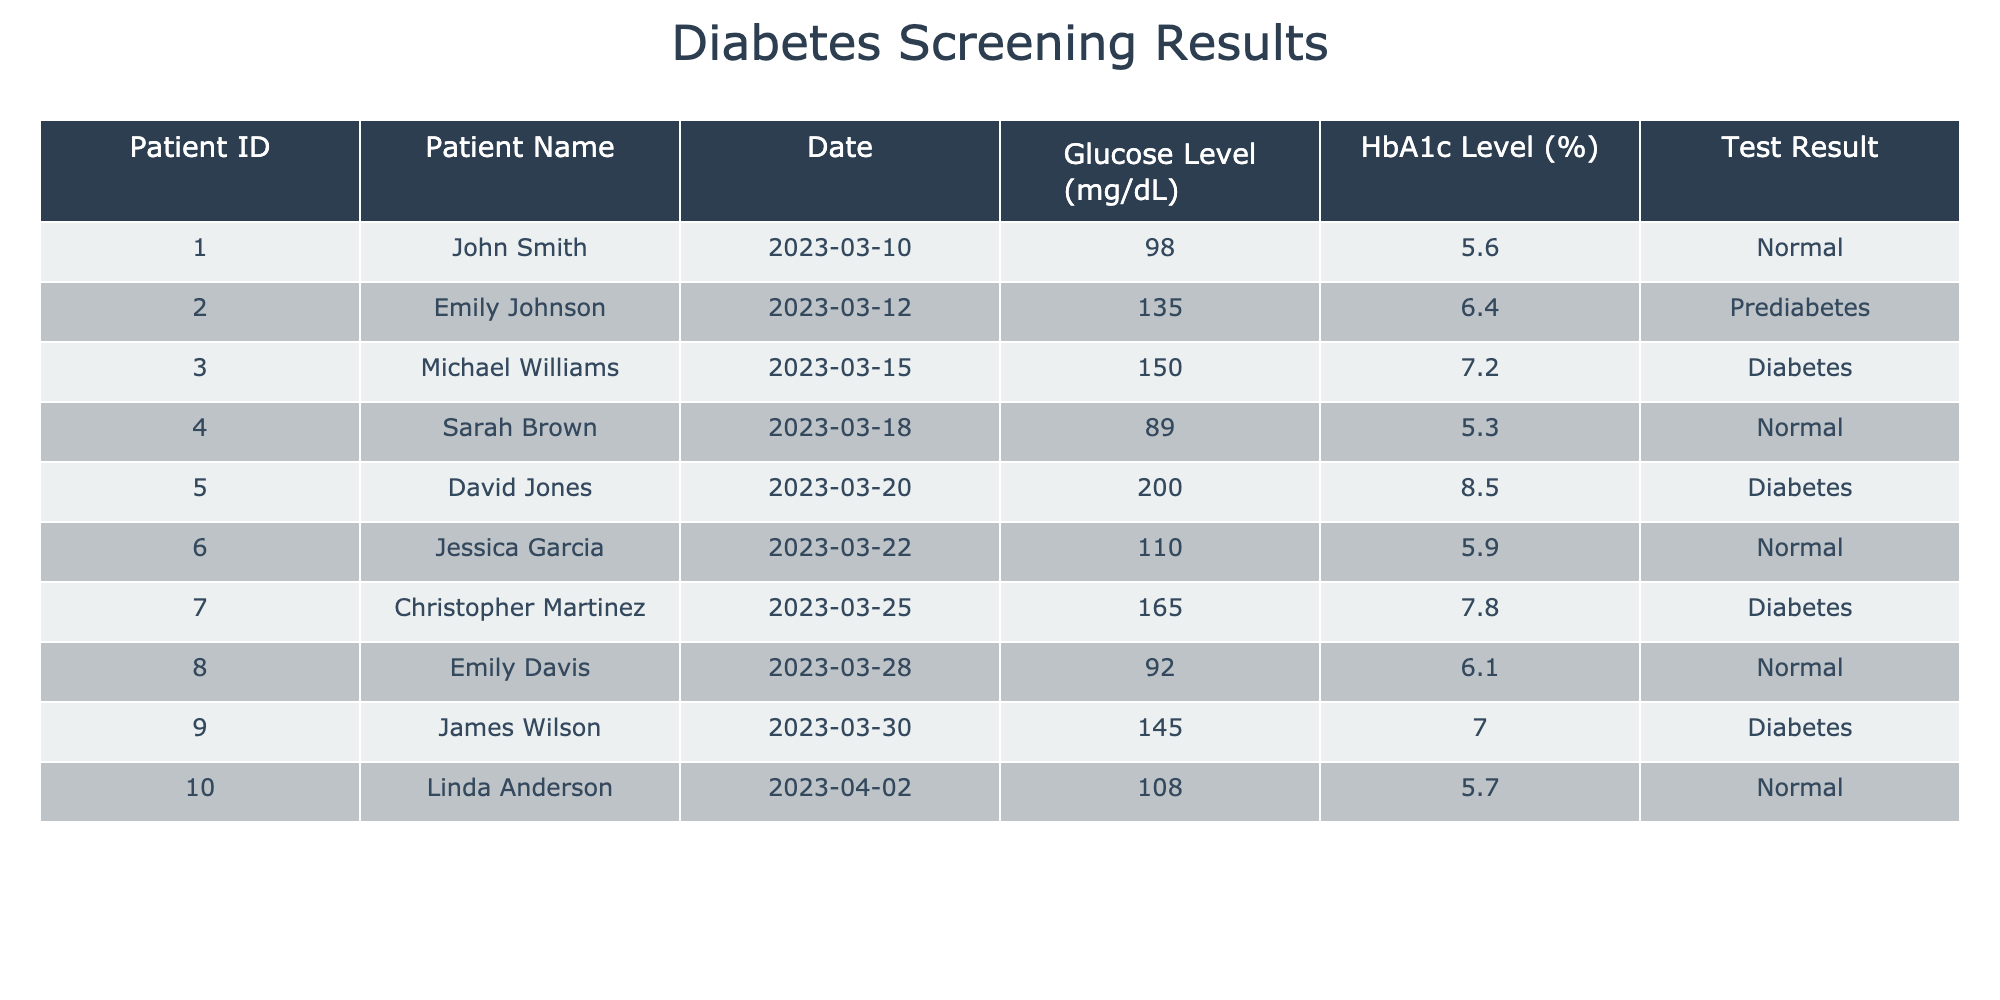What is the glucose level of Sarah Brown? From the table, I can find Sarah Brown's row, which shows her glucose level is provided directly. Looking at the data under "Glucose Level," her glucose level is 89 mg/dL.
Answer: 89 mg/dL How many patients have a normal HbA1c level? I need to count the rows where the "Test Result" column indicates "Normal." From the table, there are four patients with a normal HbA1c level: John Smith, Sarah Brown, Jessica Garcia, and Linda Anderson.
Answer: 4 What is the highest glucose level recorded, and who is the patient? To answer this, I must look for the maximum value in the "Glucose Level" column. Scanning the data, I see that David Jones has the highest glucose level at 200 mg/dL.
Answer: 200 mg/dL, David Jones Is Michael Williams diagnosed with diabetes? Referring to the "Test Result" column, I find that Michael Williams is diagnosed with diabetes, as indicated by his result of "Diabetes."
Answer: Yes What is the average HbA1c level of all patients? To find the average, I first sum up all the HbA1c levels: 5.6 + 6.4 + 7.2 + 5.3 + 8.5 + 5.9 + 7.8 + 6.1 + 7.0 + 5.7 = 60.5. There are ten patients, so I divide the sum by 10, resulting in an average of 6.05%.
Answer: 6.05% How many patients have glucose levels above 150 mg/dL? I will look for any glucose levels in the table exceeding 150 mg/dL. Examining the data, I find three patients (David Jones, Christopher Martinez, and Michael Williams) with glucose levels in that range.
Answer: 3 Which patient has the second highest HbA1c level? I need to list the HbA1c levels from highest to lowest. The highest is David Jones (8.5), then Michael Williams (7.2), followed by Christopher Martinez (7.8). Thus, the patient with the second highest HbA1c level is Christopher Martinez.
Answer: Christopher Martinez Are any patients with normal glucose levels also diagnosed with diabetes? I'll check the rows for normal glucose levels (under 100 mg/dL) while looking for the diagnosis of diabetes. After reviewing, I find that no patients meet both conditions.
Answer: No 